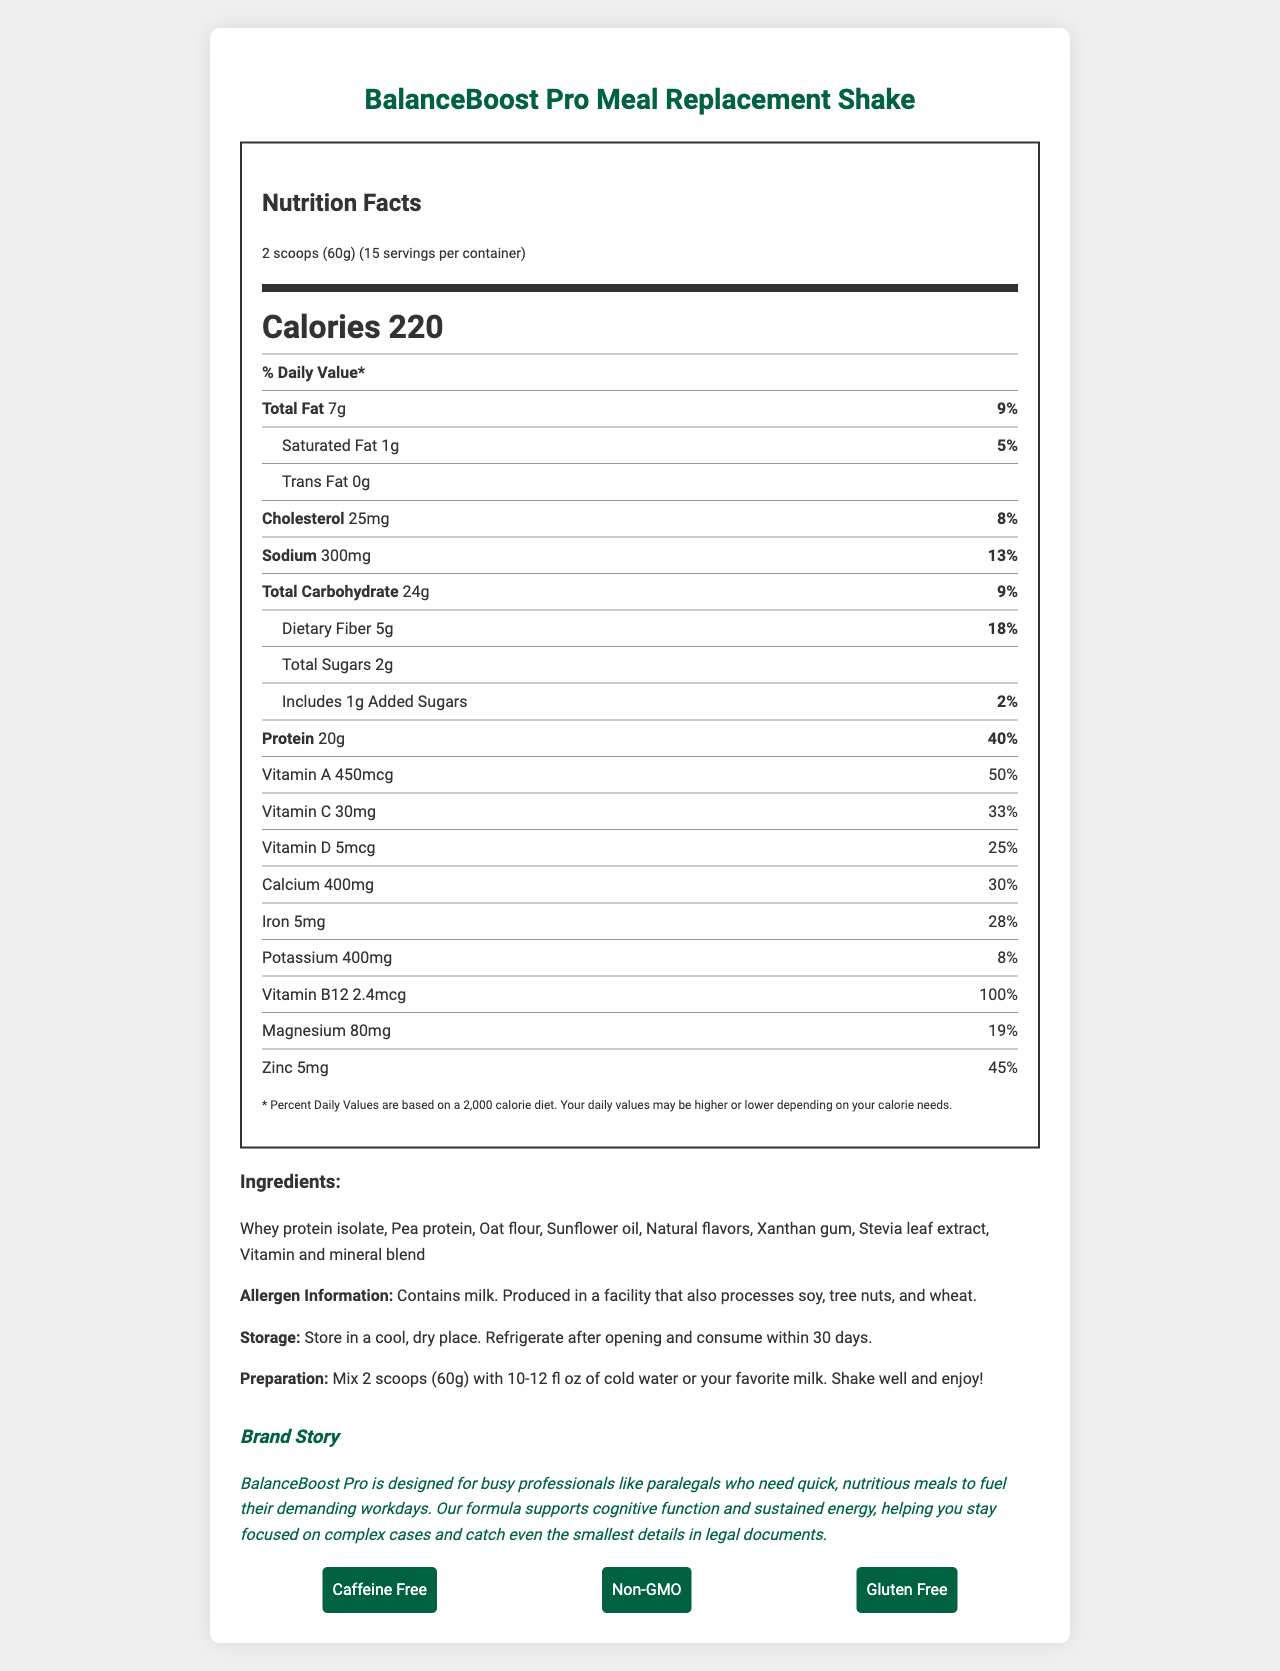what is the serving size of the BalanceBoost Pro Meal Replacement Shake? The serving size is specified at the top of the document, next to the product name.
Answer: 2 scoops (60g) how many calories are there per serving in the BalanceBoost Pro Meal Replacement Shake? The document lists the number of calories per serving prominently at the top.
Answer: 220 what is the percentage daily value of protein in the BalanceBoost Pro Meal Replacement Shake? The daily value percentage of protein is listed next to the protein amount under the nutrition facts section.
Answer: 40% how much dietary fiber does one serving contain, and what is its daily value percentage? The amount and daily value percentage of dietary fiber are displayed in the nutrition facts section.
Answer: 5g, 18% which vitamins are included in the BalanceBoost Pro Meal Replacement Shake and what are their daily value percentages? The percentages for the vitamins are listed under their respective nutrient rows in the nutrition facts section.
Answer: Vitamin A: 50%, Vitamin C: 33%, Vitamin D: 25%, Vitamin B12: 100% which of the following does the BalanceBoost Pro Meal Replacement Shake have the most of in terms of daily value percentage? A. Calcium B. Protein C. Iron D. Zinc The document shows that Protein has a daily value percentage of 40%, which is higher than the other options provided (Calcium: 30%, Iron: 28%, Zinc: 45%).
Answer: B how much sodium is included per serving of the meal replacement shake? A. 250mg B. 300mg C. 350mg D. 400mg The sodium amount per serving is listed as 300mg in the nutrition facts section.
Answer: B is the BalanceBoost Pro Meal Replacement Shake gluten-free? The gluten-free status is mentioned in the features section at the bottom of the document.
Answer: Yes summarize the main features of the BalanceBoost Pro Meal Replacement Shake. The summary combines the essential details about the nutritional benefits, key ingredients, and additional features of the product as presented in the document.
Answer: The BalanceBoost Pro Meal Replacement Shake is a nutritious product designed for busy professionals, offering 220 calories per serving with 20g of protein and various essential vitamins and minerals. It is caffeine-free, non-GMO, and gluten-free with ingredients like whey protein isolate, pea protein, and oat flour. It contains milk and is produced in a facility that processes soy, tree nuts, and wheat. what main allergen is present in the BalanceBoost Pro Meal Replacement Shake? The allergen information clearly states that the product contains milk.
Answer: Milk how many servings are in one container of the BalanceBoost Pro Meal Replacement Shake? The number of servings per container is listed at the top next to the serving size information.
Answer: 15 what is the preparation instruction for the BalanceBoost Pro Meal Replacement Shake? The preparation instructions are provided below the nutritional information.
Answer: Mix 2 scoops (60g) with 10-12 fl oz of cold water or your favorite milk. Shake well and enjoy! what is the mission of the BalanceBoost Pro brand as described in the document? The brand story section describes the mission of BalanceBoost Pro.
Answer: The brand aims to provide nutritious meals for busy professionals to support cognitive function and sustained energy. does the BalanceBoost Pro Meal Replacement Shake contain any added sugars? The nutrition facts indicate that the product contains 1g of added sugars.
Answer: Yes what is the daily value percentage of magnesium in the product? The daily value percentage for magnesium is listed under its nutrient row in the nutrition facts section.
Answer: 19% what is the source of plant-based protein in the BalanceBoost Pro Meal Replacement Shake? The ingredients list includes pea protein among the sources of protein.
Answer: Pea protein what is the main ingredient in the vitamin and mineral blend? The document lists "vitamin and mineral blend" as an ingredient, but it does not specify the main ingredient within this blend.
Answer: Cannot be determined 